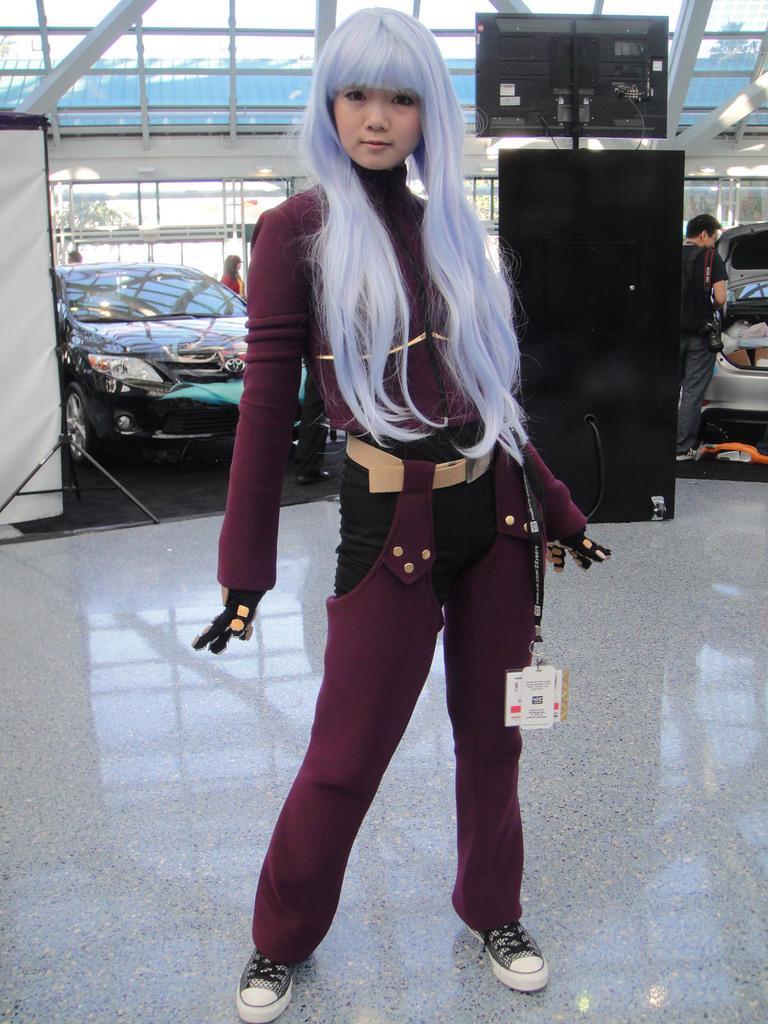In one or two sentences, can you explain what this image depicts? In this picture there is a woman standing. At the back there are vehicles and there are group of people and there is a television. Behind the glass wall there are trees. At the top there is a roof. At the bottom there is a reflection of the roof on the floor. On the left side of the image there is a screen. 